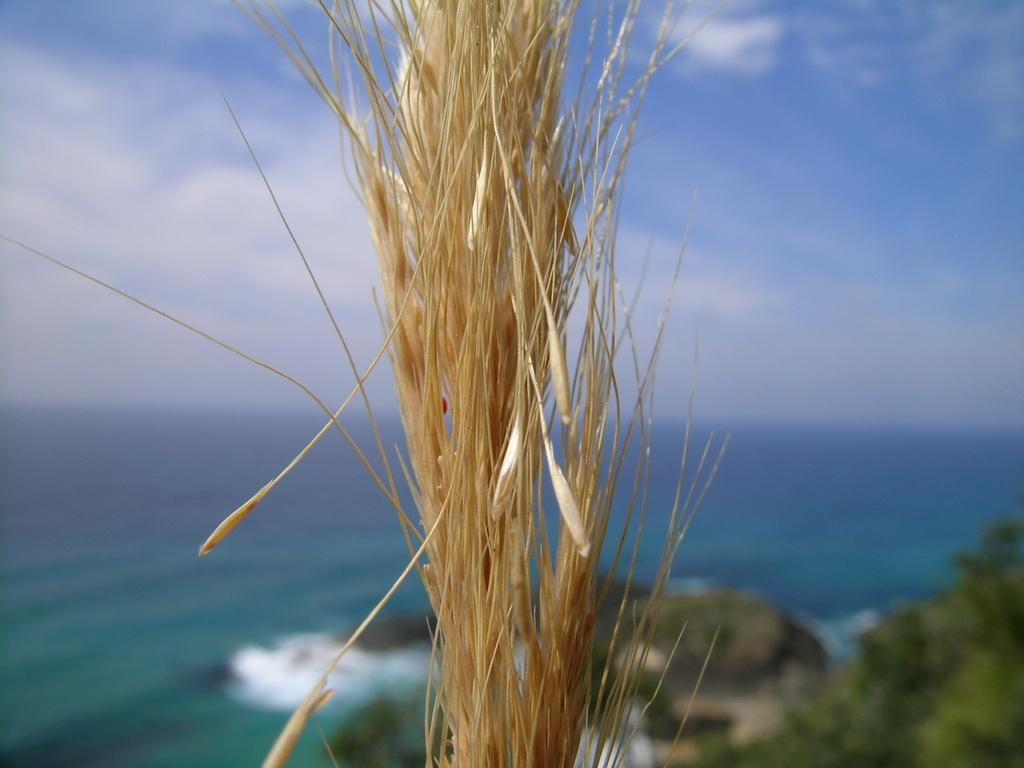What type of living organism can be seen in the image? There is a plant in the image. What is the color of the plant? The plant is brown in color. What can be seen in the background of the image? There is water, trees, rocks, and the sky visible in the background of the image. How does the plant receive a haircut in the image? The plant does not receive a haircut in the image, as plants do not have hair. 